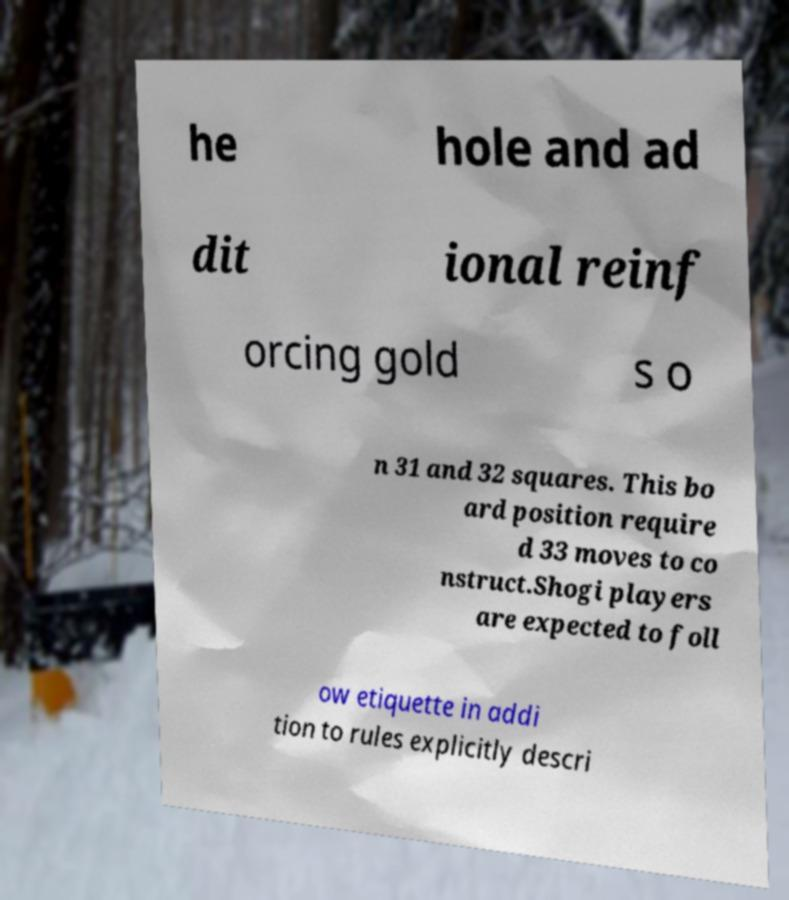There's text embedded in this image that I need extracted. Can you transcribe it verbatim? he hole and ad dit ional reinf orcing gold s o n 31 and 32 squares. This bo ard position require d 33 moves to co nstruct.Shogi players are expected to foll ow etiquette in addi tion to rules explicitly descri 